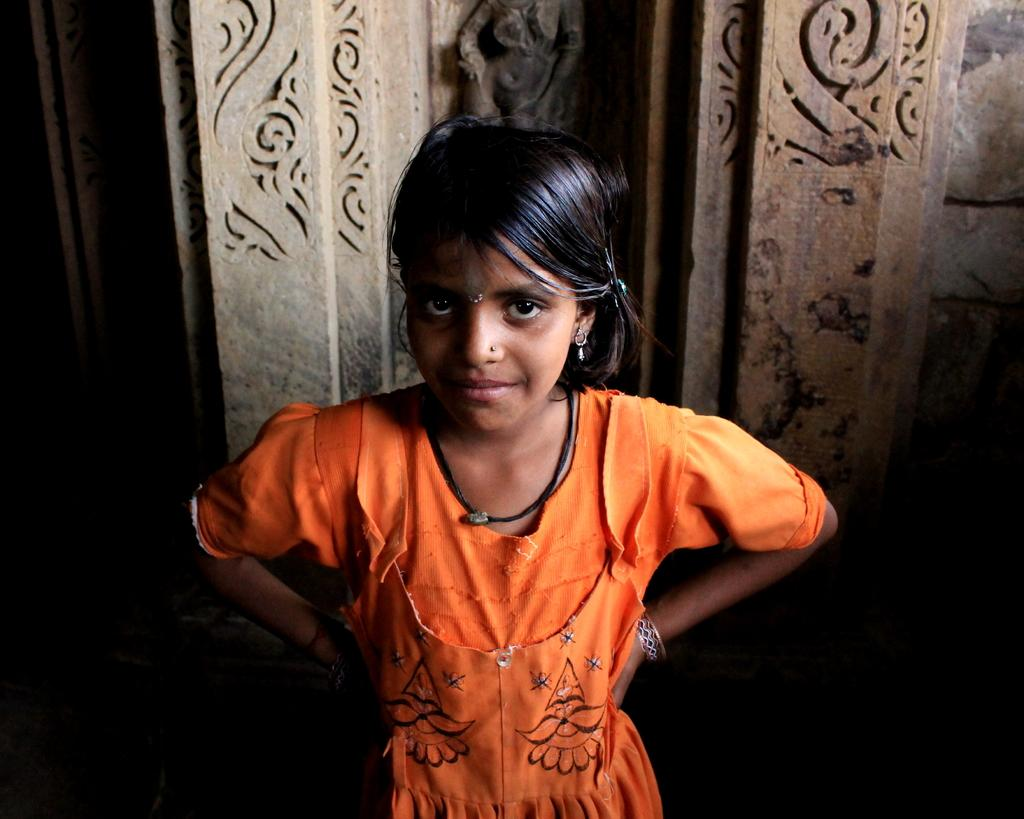Who is the main subject in the picture? There is a girl in the picture. What is the girl doing in the picture? The girl is standing. What can be seen in the background of the picture? There is a wall in the background of the picture. What type of smoke can be seen coming from the girl's hand in the picture? There is no smoke present in the image, and the girl's hand is not shown. 